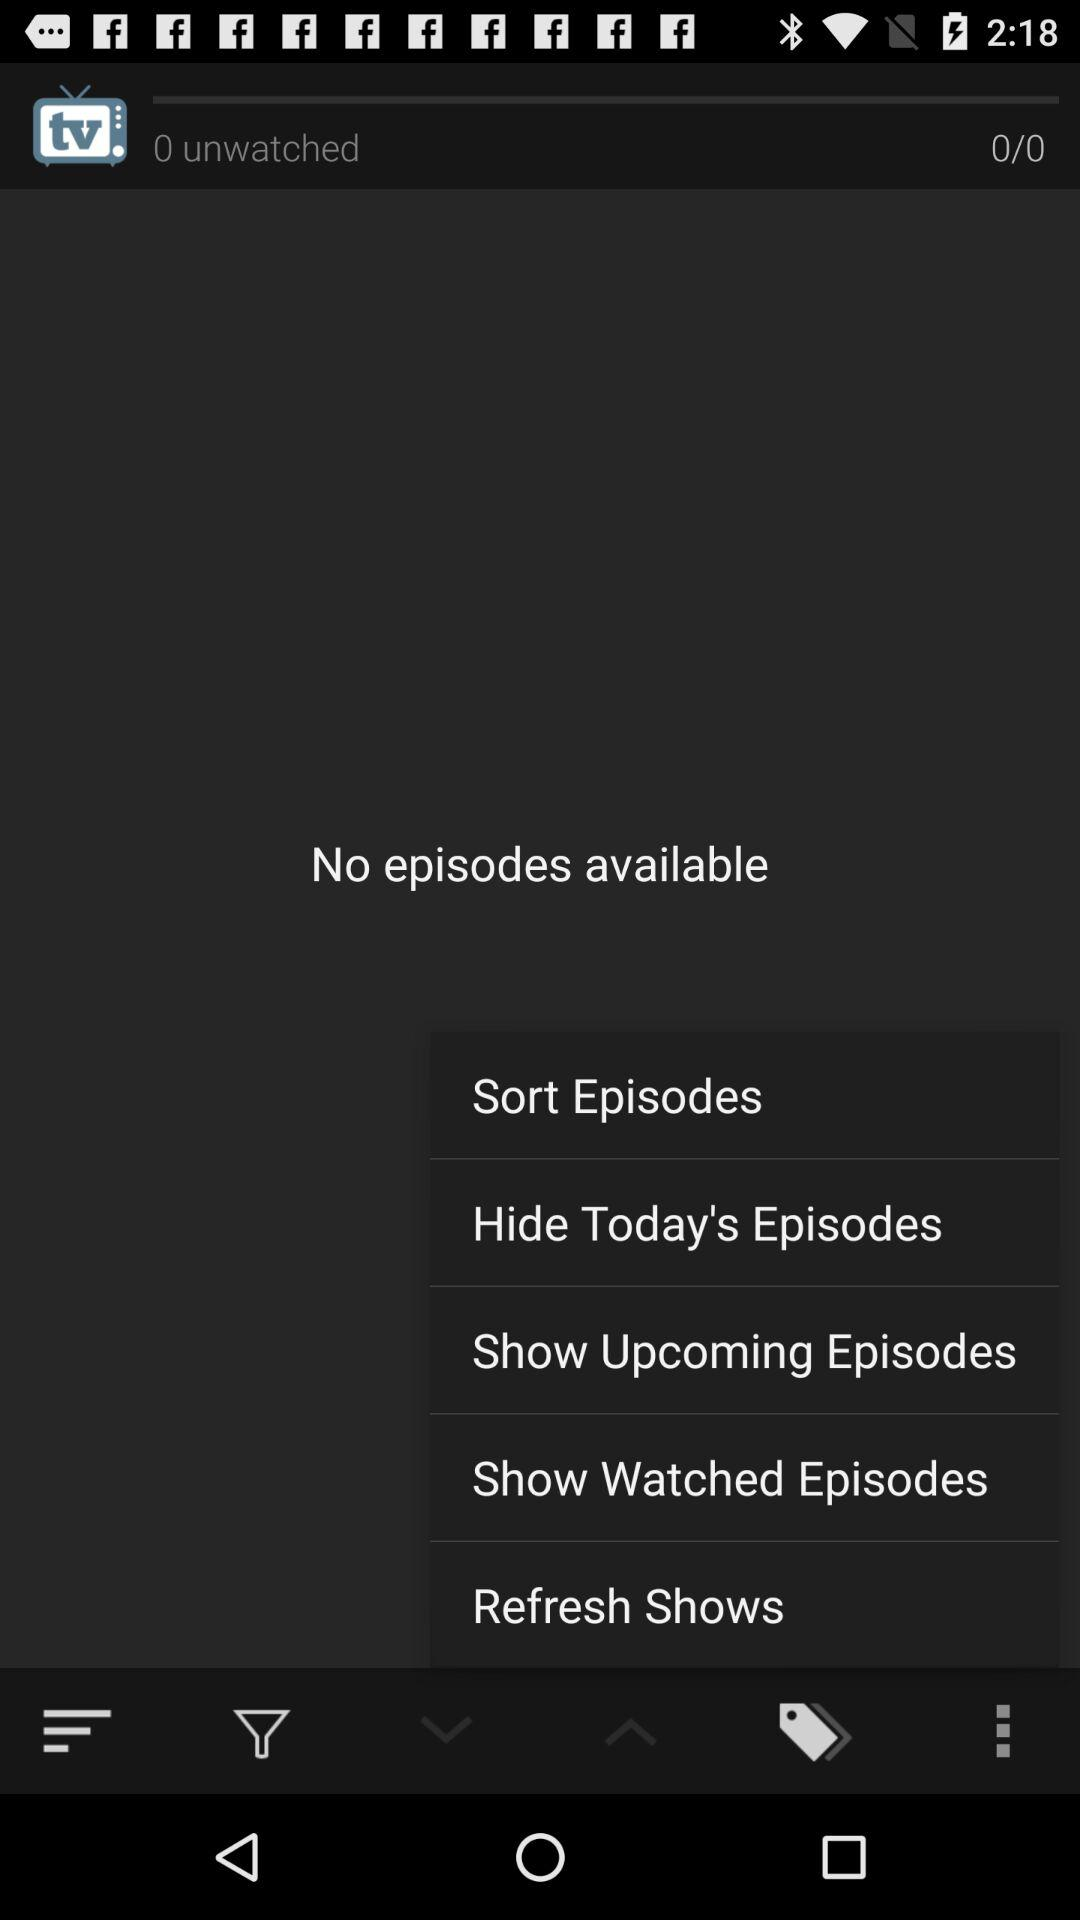Which episode option is selected?
When the provided information is insufficient, respond with <no answer>. <no answer> 